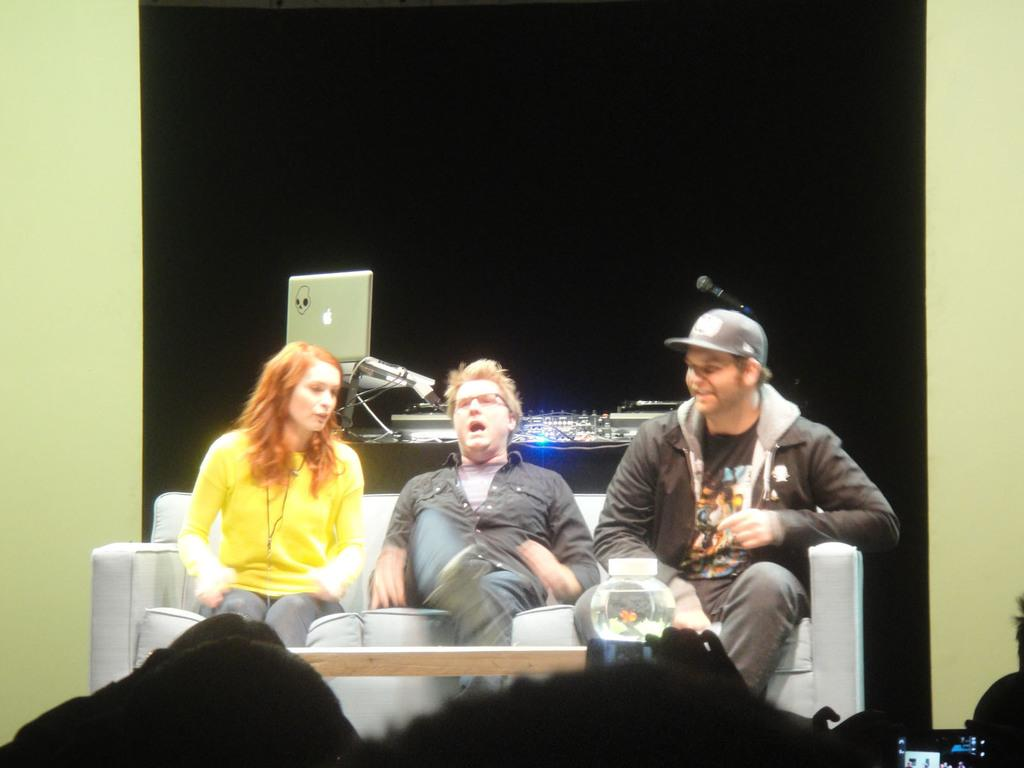How many people are in the image? There is a group of people in the image. What are the people doing in the image? The people are sitting on a sofa. What is on the table in front of the sofa? An aquarium is present on the table. What is behind the people in the image? There is a screen with a computer and other things behind the people. How many balloons are tied to the sofa in the image? There are no balloons present in the image. What trick is the group of people performing in the image? There is no trick being performed in the image; the people are simply sitting on the sofa. 